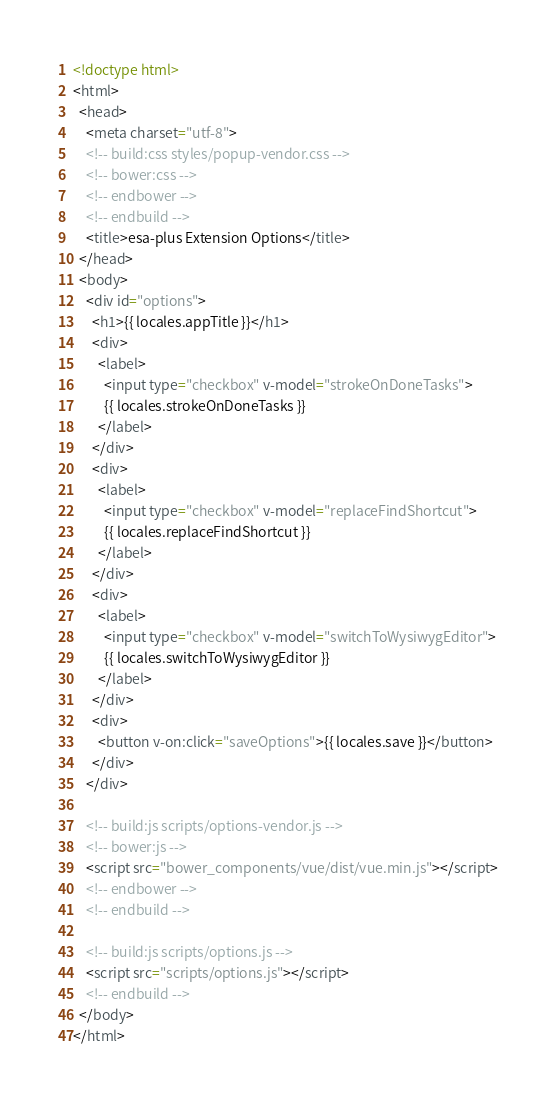<code> <loc_0><loc_0><loc_500><loc_500><_HTML_><!doctype html>
<html>
  <head>
    <meta charset="utf-8">
    <!-- build:css styles/popup-vendor.css -->
    <!-- bower:css -->
    <!-- endbower -->
    <!-- endbuild -->
    <title>esa-plus Extension Options</title>
  </head>
  <body>
    <div id="options">
      <h1>{{ locales.appTitle }}</h1>
      <div>
        <label>
          <input type="checkbox" v-model="strokeOnDoneTasks">
          {{ locales.strokeOnDoneTasks }}
        </label>
      </div>
      <div>
        <label>
          <input type="checkbox" v-model="replaceFindShortcut">
          {{ locales.replaceFindShortcut }}
        </label>
      </div>
      <div>
        <label>
          <input type="checkbox" v-model="switchToWysiwygEditor">
          {{ locales.switchToWysiwygEditor }}
        </label>
      </div>
      <div>
        <button v-on:click="saveOptions">{{ locales.save }}</button>
      </div>
    </div>

    <!-- build:js scripts/options-vendor.js -->
    <!-- bower:js -->
    <script src="bower_components/vue/dist/vue.min.js"></script>
    <!-- endbower -->
    <!-- endbuild -->

    <!-- build:js scripts/options.js -->
    <script src="scripts/options.js"></script>
    <!-- endbuild -->
  </body>
</html>
</code> 